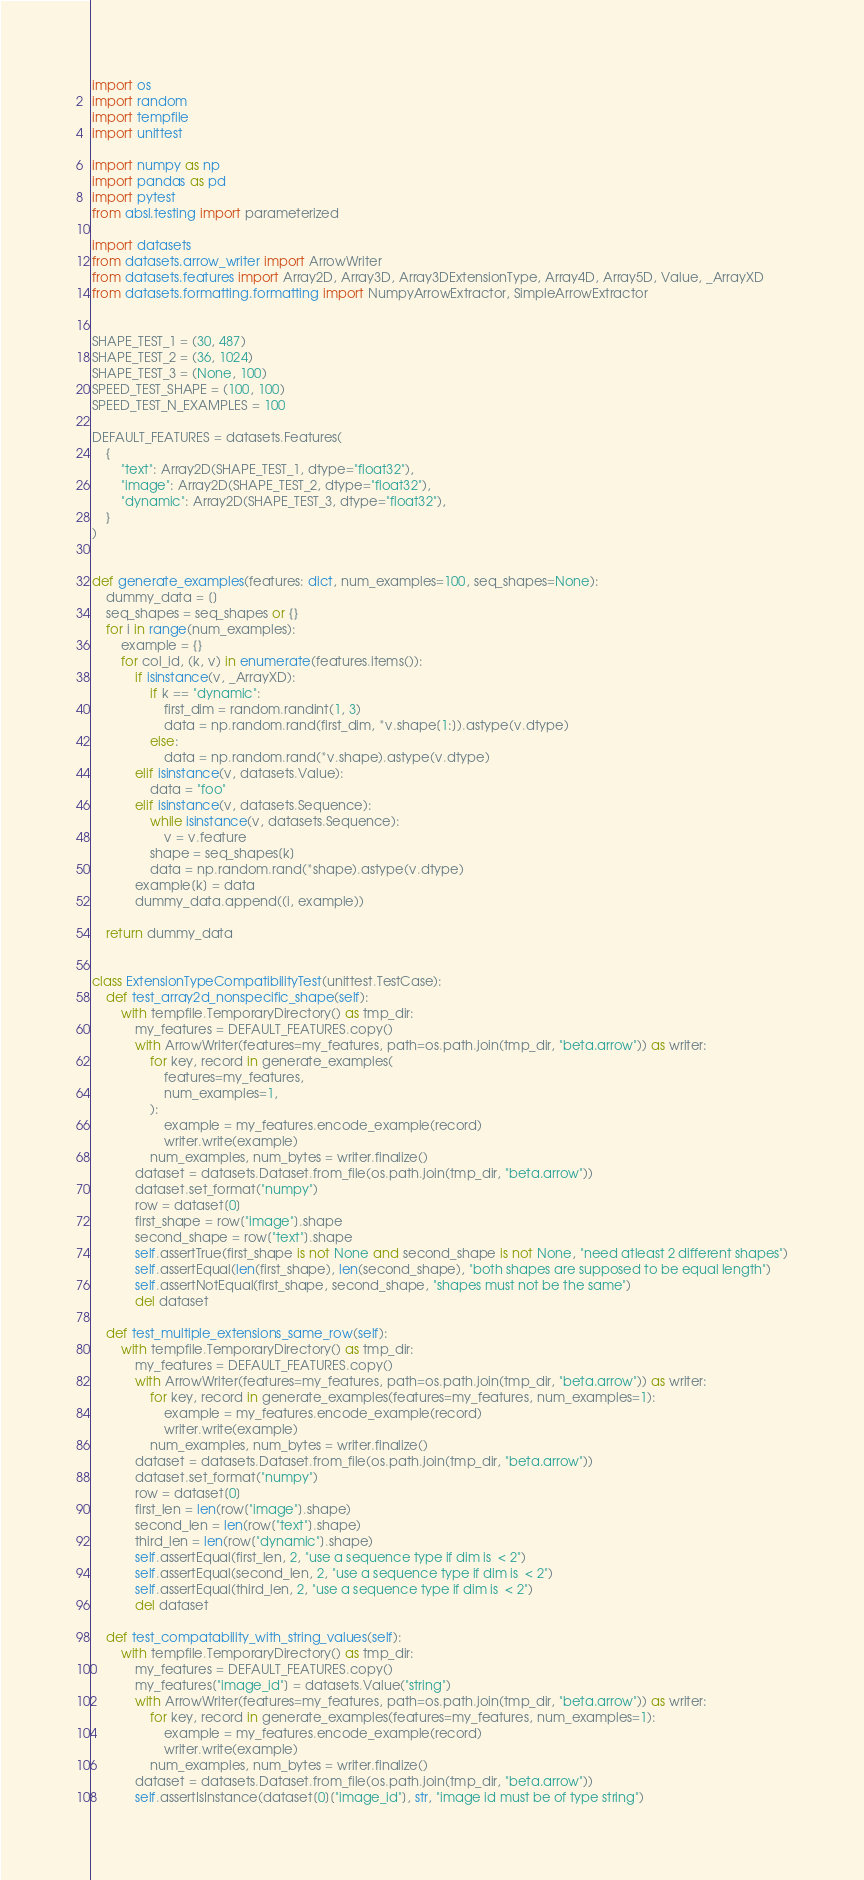<code> <loc_0><loc_0><loc_500><loc_500><_Python_>import os
import random
import tempfile
import unittest

import numpy as np
import pandas as pd
import pytest
from absl.testing import parameterized

import datasets
from datasets.arrow_writer import ArrowWriter
from datasets.features import Array2D, Array3D, Array3DExtensionType, Array4D, Array5D, Value, _ArrayXD
from datasets.formatting.formatting import NumpyArrowExtractor, SimpleArrowExtractor


SHAPE_TEST_1 = (30, 487)
SHAPE_TEST_2 = (36, 1024)
SHAPE_TEST_3 = (None, 100)
SPEED_TEST_SHAPE = (100, 100)
SPEED_TEST_N_EXAMPLES = 100

DEFAULT_FEATURES = datasets.Features(
    {
        "text": Array2D(SHAPE_TEST_1, dtype="float32"),
        "image": Array2D(SHAPE_TEST_2, dtype="float32"),
        "dynamic": Array2D(SHAPE_TEST_3, dtype="float32"),
    }
)


def generate_examples(features: dict, num_examples=100, seq_shapes=None):
    dummy_data = []
    seq_shapes = seq_shapes or {}
    for i in range(num_examples):
        example = {}
        for col_id, (k, v) in enumerate(features.items()):
            if isinstance(v, _ArrayXD):
                if k == "dynamic":
                    first_dim = random.randint(1, 3)
                    data = np.random.rand(first_dim, *v.shape[1:]).astype(v.dtype)
                else:
                    data = np.random.rand(*v.shape).astype(v.dtype)
            elif isinstance(v, datasets.Value):
                data = "foo"
            elif isinstance(v, datasets.Sequence):
                while isinstance(v, datasets.Sequence):
                    v = v.feature
                shape = seq_shapes[k]
                data = np.random.rand(*shape).astype(v.dtype)
            example[k] = data
            dummy_data.append((i, example))

    return dummy_data


class ExtensionTypeCompatibilityTest(unittest.TestCase):
    def test_array2d_nonspecific_shape(self):
        with tempfile.TemporaryDirectory() as tmp_dir:
            my_features = DEFAULT_FEATURES.copy()
            with ArrowWriter(features=my_features, path=os.path.join(tmp_dir, "beta.arrow")) as writer:
                for key, record in generate_examples(
                    features=my_features,
                    num_examples=1,
                ):
                    example = my_features.encode_example(record)
                    writer.write(example)
                num_examples, num_bytes = writer.finalize()
            dataset = datasets.Dataset.from_file(os.path.join(tmp_dir, "beta.arrow"))
            dataset.set_format("numpy")
            row = dataset[0]
            first_shape = row["image"].shape
            second_shape = row["text"].shape
            self.assertTrue(first_shape is not None and second_shape is not None, "need atleast 2 different shapes")
            self.assertEqual(len(first_shape), len(second_shape), "both shapes are supposed to be equal length")
            self.assertNotEqual(first_shape, second_shape, "shapes must not be the same")
            del dataset

    def test_multiple_extensions_same_row(self):
        with tempfile.TemporaryDirectory() as tmp_dir:
            my_features = DEFAULT_FEATURES.copy()
            with ArrowWriter(features=my_features, path=os.path.join(tmp_dir, "beta.arrow")) as writer:
                for key, record in generate_examples(features=my_features, num_examples=1):
                    example = my_features.encode_example(record)
                    writer.write(example)
                num_examples, num_bytes = writer.finalize()
            dataset = datasets.Dataset.from_file(os.path.join(tmp_dir, "beta.arrow"))
            dataset.set_format("numpy")
            row = dataset[0]
            first_len = len(row["image"].shape)
            second_len = len(row["text"].shape)
            third_len = len(row["dynamic"].shape)
            self.assertEqual(first_len, 2, "use a sequence type if dim is  < 2")
            self.assertEqual(second_len, 2, "use a sequence type if dim is  < 2")
            self.assertEqual(third_len, 2, "use a sequence type if dim is  < 2")
            del dataset

    def test_compatability_with_string_values(self):
        with tempfile.TemporaryDirectory() as tmp_dir:
            my_features = DEFAULT_FEATURES.copy()
            my_features["image_id"] = datasets.Value("string")
            with ArrowWriter(features=my_features, path=os.path.join(tmp_dir, "beta.arrow")) as writer:
                for key, record in generate_examples(features=my_features, num_examples=1):
                    example = my_features.encode_example(record)
                    writer.write(example)
                num_examples, num_bytes = writer.finalize()
            dataset = datasets.Dataset.from_file(os.path.join(tmp_dir, "beta.arrow"))
            self.assertIsInstance(dataset[0]["image_id"], str, "image id must be of type string")</code> 